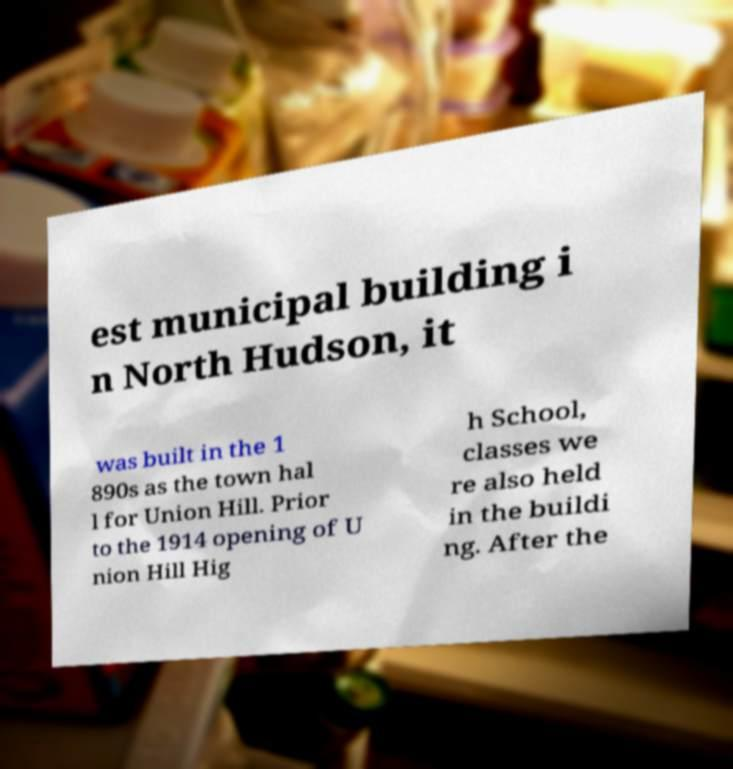Can you read and provide the text displayed in the image?This photo seems to have some interesting text. Can you extract and type it out for me? est municipal building i n North Hudson, it was built in the 1 890s as the town hal l for Union Hill. Prior to the 1914 opening of U nion Hill Hig h School, classes we re also held in the buildi ng. After the 